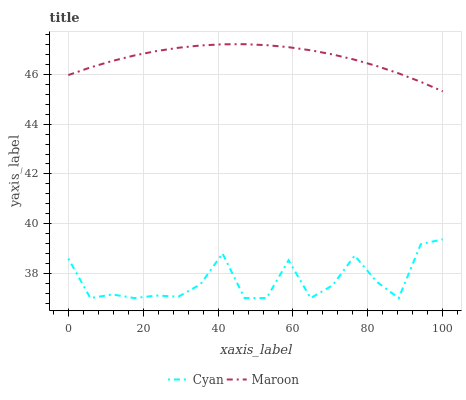Does Cyan have the minimum area under the curve?
Answer yes or no. Yes. Does Maroon have the maximum area under the curve?
Answer yes or no. Yes. Does Maroon have the minimum area under the curve?
Answer yes or no. No. Is Maroon the smoothest?
Answer yes or no. Yes. Is Cyan the roughest?
Answer yes or no. Yes. Is Maroon the roughest?
Answer yes or no. No. Does Maroon have the lowest value?
Answer yes or no. No. Does Maroon have the highest value?
Answer yes or no. Yes. Is Cyan less than Maroon?
Answer yes or no. Yes. Is Maroon greater than Cyan?
Answer yes or no. Yes. Does Cyan intersect Maroon?
Answer yes or no. No. 